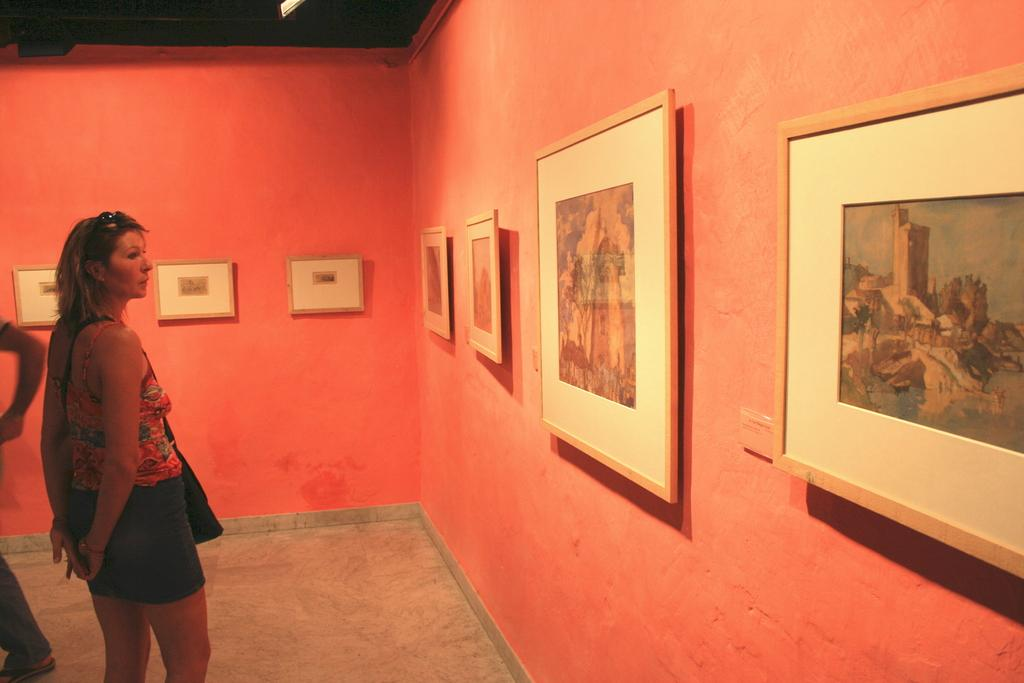What is the main subject of the image? There is a woman standing in the image. What can be seen on the wall in the image? There are frames on the wall in the image. Who is beside the woman in the image? There is a person beside the woman in the image. What type of star can be seen in the image? There is no star present in the image. Can you describe the branch that the woman is holding in the image? There is no branch visible in the image; the woman is not holding anything. 